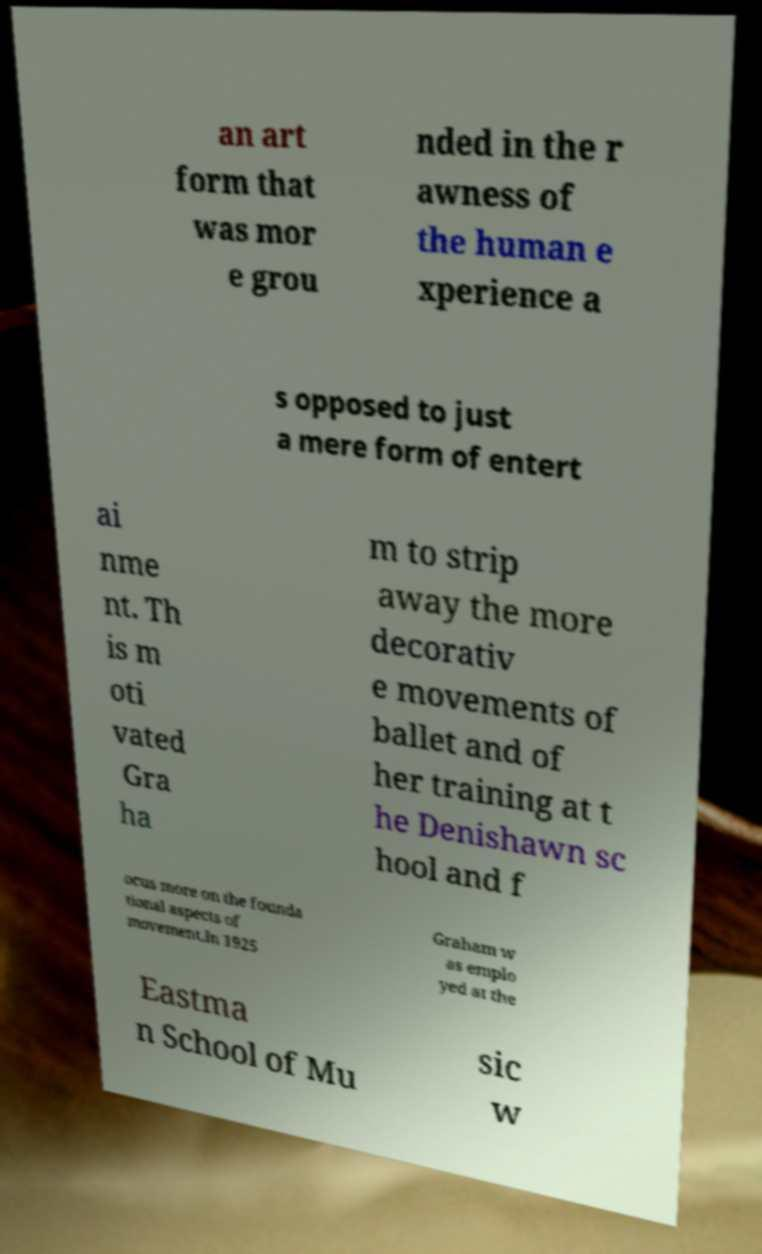Can you accurately transcribe the text from the provided image for me? an art form that was mor e grou nded in the r awness of the human e xperience a s opposed to just a mere form of entert ai nme nt. Th is m oti vated Gra ha m to strip away the more decorativ e movements of ballet and of her training at t he Denishawn sc hool and f ocus more on the founda tional aspects of movement.In 1925 Graham w as emplo yed at the Eastma n School of Mu sic w 